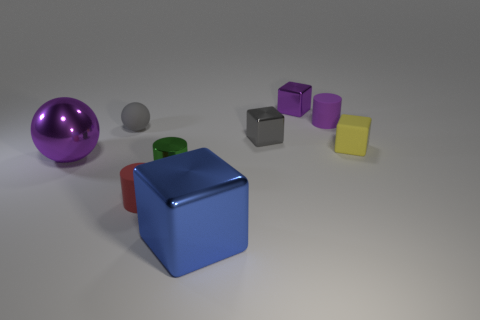Add 1 large yellow rubber objects. How many objects exist? 10 Subtract all blocks. How many objects are left? 5 Subtract all green shiny cylinders. Subtract all small yellow matte cubes. How many objects are left? 7 Add 7 gray blocks. How many gray blocks are left? 8 Add 3 yellow matte things. How many yellow matte things exist? 4 Subtract 0 yellow spheres. How many objects are left? 9 